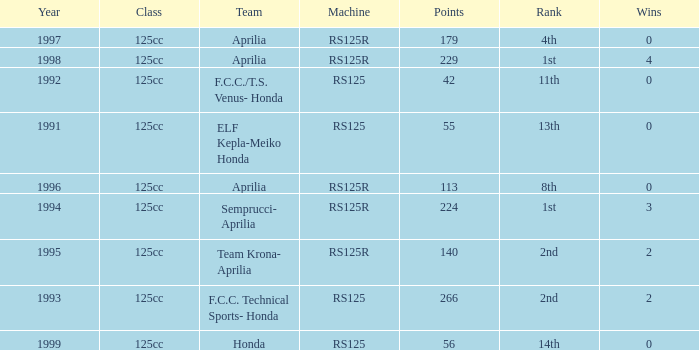Which team had a year over 1995, machine of RS125R, and ranked 1st? Aprilia. 